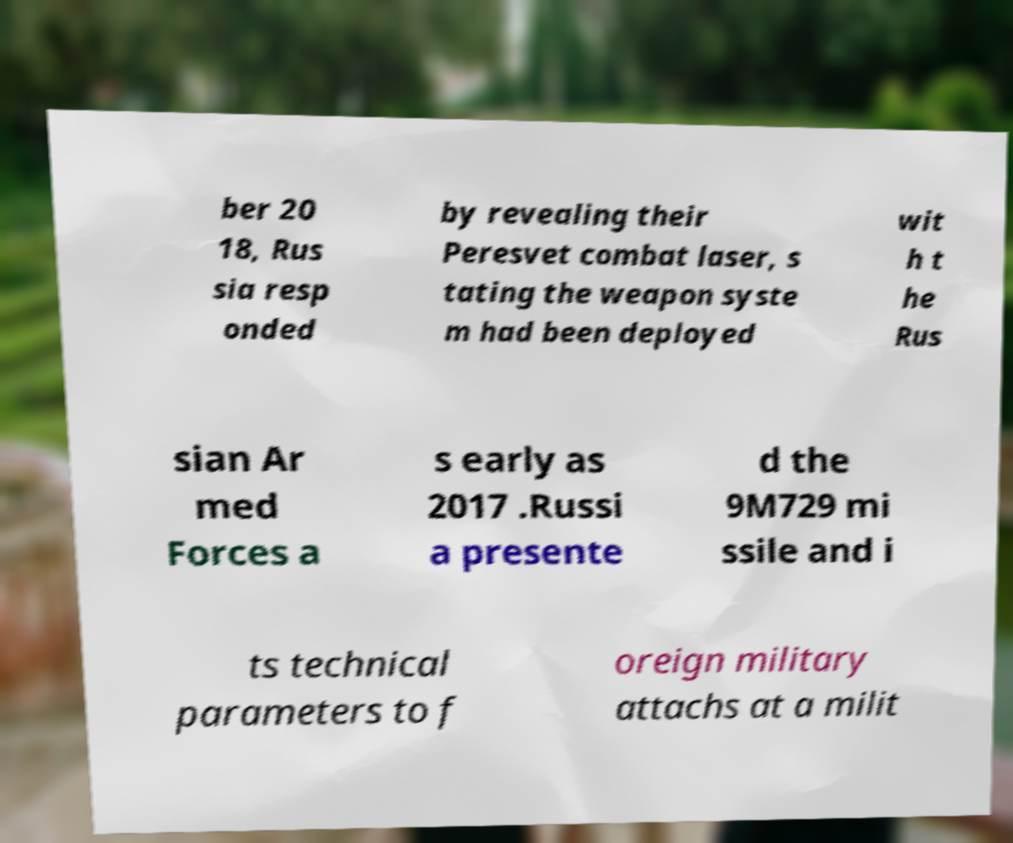Please identify and transcribe the text found in this image. ber 20 18, Rus sia resp onded by revealing their Peresvet combat laser, s tating the weapon syste m had been deployed wit h t he Rus sian Ar med Forces a s early as 2017 .Russi a presente d the 9M729 mi ssile and i ts technical parameters to f oreign military attachs at a milit 